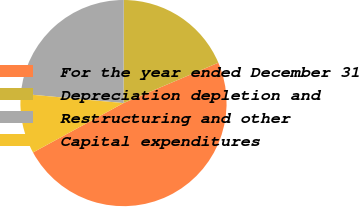Convert chart. <chart><loc_0><loc_0><loc_500><loc_500><pie_chart><fcel>For the year ended December 31<fcel>Depreciation depletion and<fcel>Restructuring and other<fcel>Capital expenditures<nl><fcel>48.45%<fcel>18.56%<fcel>23.59%<fcel>9.4%<nl></chart> 